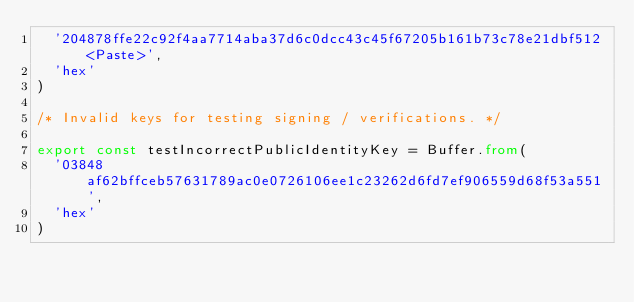<code> <loc_0><loc_0><loc_500><loc_500><_TypeScript_>  '204878ffe22c92f4aa7714aba37d6c0dcc43c45f67205b161b73c78e21dbf512<Paste>',
  'hex'
)

/* Invalid keys for testing signing / verifications. */

export const testIncorrectPublicIdentityKey = Buffer.from(
  '03848af62bffceb57631789ac0e0726106ee1c23262d6fd7ef906559d68f53a551',
  'hex'
)</code> 